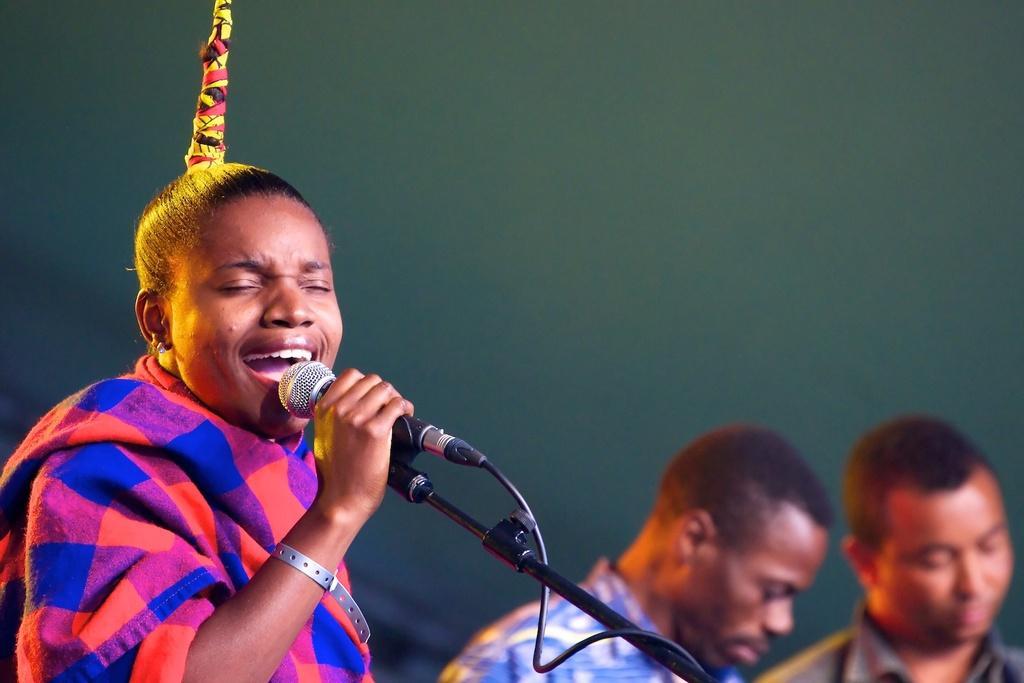Can you describe this image briefly? In this picture there is a person holding the microphone and singing and there are two persons. At the back there is a green color background. 